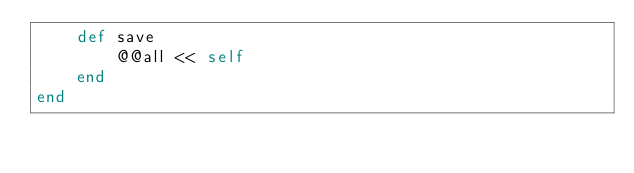<code> <loc_0><loc_0><loc_500><loc_500><_Ruby_>    def save
        @@all << self 
    end
end
</code> 